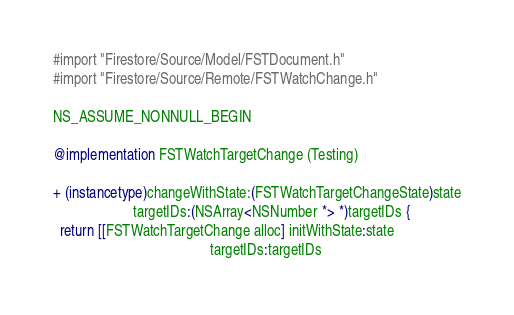<code> <loc_0><loc_0><loc_500><loc_500><_ObjectiveC_>#import "Firestore/Source/Model/FSTDocument.h"
#import "Firestore/Source/Remote/FSTWatchChange.h"

NS_ASSUME_NONNULL_BEGIN

@implementation FSTWatchTargetChange (Testing)

+ (instancetype)changeWithState:(FSTWatchTargetChangeState)state
                      targetIDs:(NSArray<NSNumber *> *)targetIDs {
  return [[FSTWatchTargetChange alloc] initWithState:state
                                           targetIDs:targetIDs</code> 